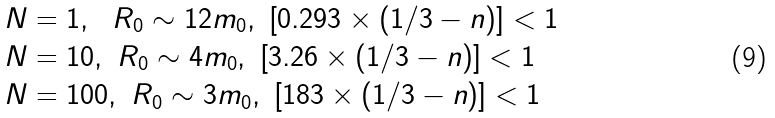Convert formula to latex. <formula><loc_0><loc_0><loc_500><loc_500>N & = 1 , \text { \ } R _ { 0 } \sim 1 2 m _ { 0 } , \text { } [ 0 . 2 9 3 \times ( 1 / 3 - n ) ] < 1 \\ N & = 1 0 , \text { } R _ { 0 } \sim 4 m _ { 0 } , \text { } [ 3 . 2 6 \times ( 1 / 3 - n ) ] < 1 \\ N & = 1 0 0 , \text { } R _ { 0 } \sim 3 m _ { 0 } , \text { } [ 1 8 3 \times ( 1 / 3 - n ) ] < 1</formula> 